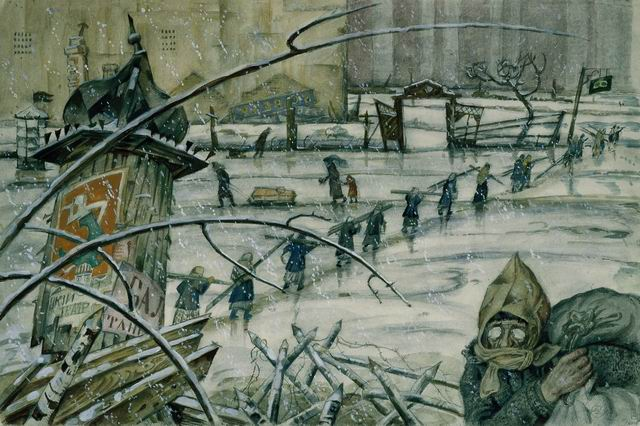Imagine what the people in the image might be thinking. Can you describe their thoughts in detail? In the midst of the harsh winter environment, the thoughts of the people trudging through the snow might be filled with fear, uncertainty, and a desperate hope for safety. The person in the gas mask might be feeling a mix of determination to survive and anxiety about the unseen threats, be they chemical or simply the relentless cold. Those carrying heavy sacks could be thinking about the homes and lives they’ve left behind, mourning losses while clinging to what little they have left. Their thoughts likely range from reminiscing about better days to strategizing their next steps for survival in this ravaged city. 